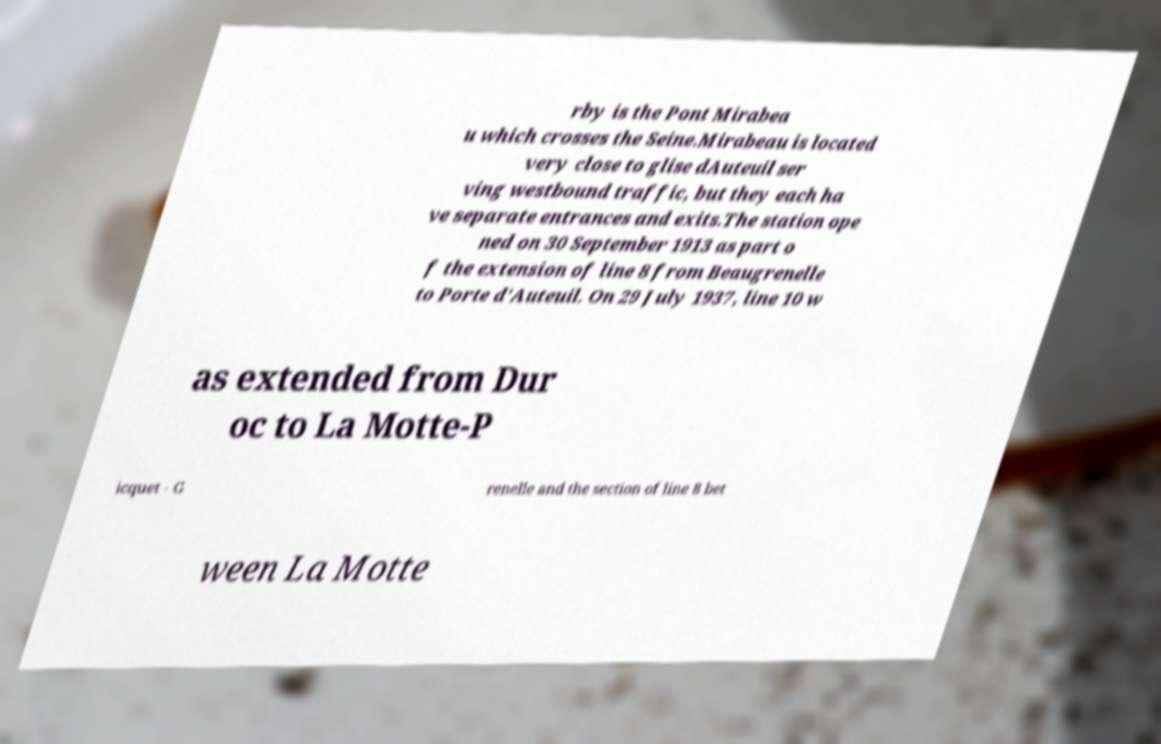Can you accurately transcribe the text from the provided image for me? rby is the Pont Mirabea u which crosses the Seine.Mirabeau is located very close to glise dAuteuil ser ving westbound traffic, but they each ha ve separate entrances and exits.The station ope ned on 30 September 1913 as part o f the extension of line 8 from Beaugrenelle to Porte d'Auteuil. On 29 July 1937, line 10 w as extended from Dur oc to La Motte-P icquet - G renelle and the section of line 8 bet ween La Motte 